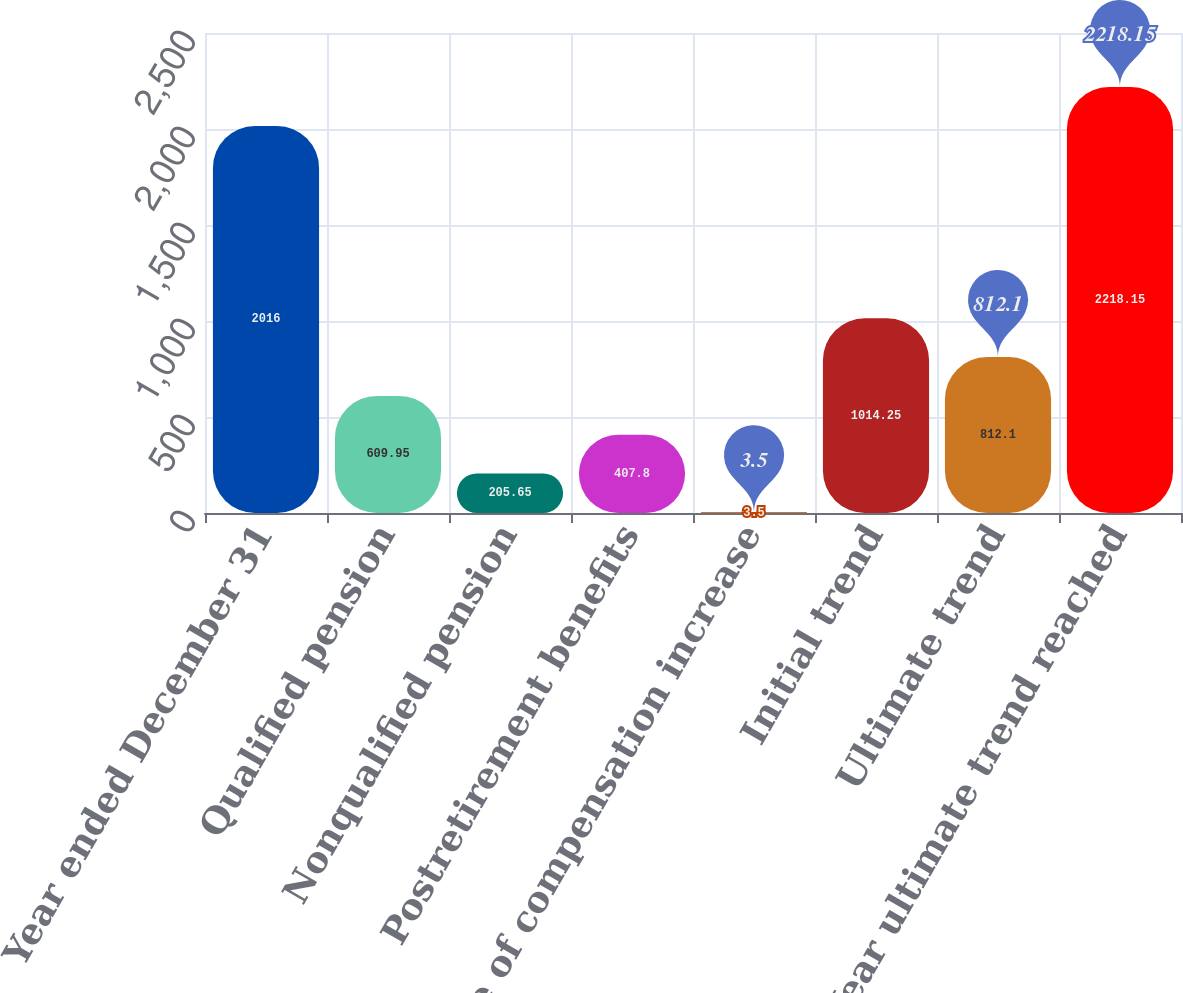Convert chart. <chart><loc_0><loc_0><loc_500><loc_500><bar_chart><fcel>Year ended December 31<fcel>Qualified pension<fcel>Nonqualified pension<fcel>Postretirement benefits<fcel>Rate of compensation increase<fcel>Initial trend<fcel>Ultimate trend<fcel>Year ultimate trend reached<nl><fcel>2016<fcel>609.95<fcel>205.65<fcel>407.8<fcel>3.5<fcel>1014.25<fcel>812.1<fcel>2218.15<nl></chart> 